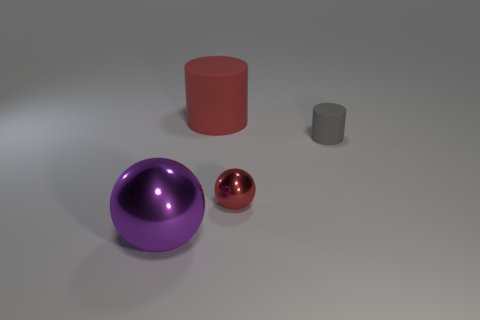There is a rubber cylinder that is the same color as the small metal object; what size is it?
Offer a terse response. Large. Are there the same number of objects right of the big purple metallic object and metal objects that are on the right side of the large red rubber object?
Ensure brevity in your answer.  No. Does the metallic sphere that is right of the purple shiny ball have the same size as the shiny thing to the left of the red sphere?
Your answer should be compact. No. How many rubber objects are the same color as the small metallic object?
Ensure brevity in your answer.  1. There is a object that is the same color as the tiny ball; what material is it?
Your answer should be very brief. Rubber. Is the number of small rubber cylinders behind the large purple thing greater than the number of metallic cylinders?
Offer a terse response. Yes. Is the shape of the large purple shiny object the same as the tiny red metallic object?
Offer a very short reply. Yes. What number of red things have the same material as the big cylinder?
Your answer should be compact. 0. The other gray thing that is the same shape as the large rubber thing is what size?
Keep it short and to the point. Small. Do the red metallic sphere and the red matte cylinder have the same size?
Keep it short and to the point. No. 